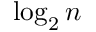Convert formula to latex. <formula><loc_0><loc_0><loc_500><loc_500>\log _ { 2 } n</formula> 